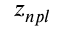<formula> <loc_0><loc_0><loc_500><loc_500>z _ { n p l }</formula> 